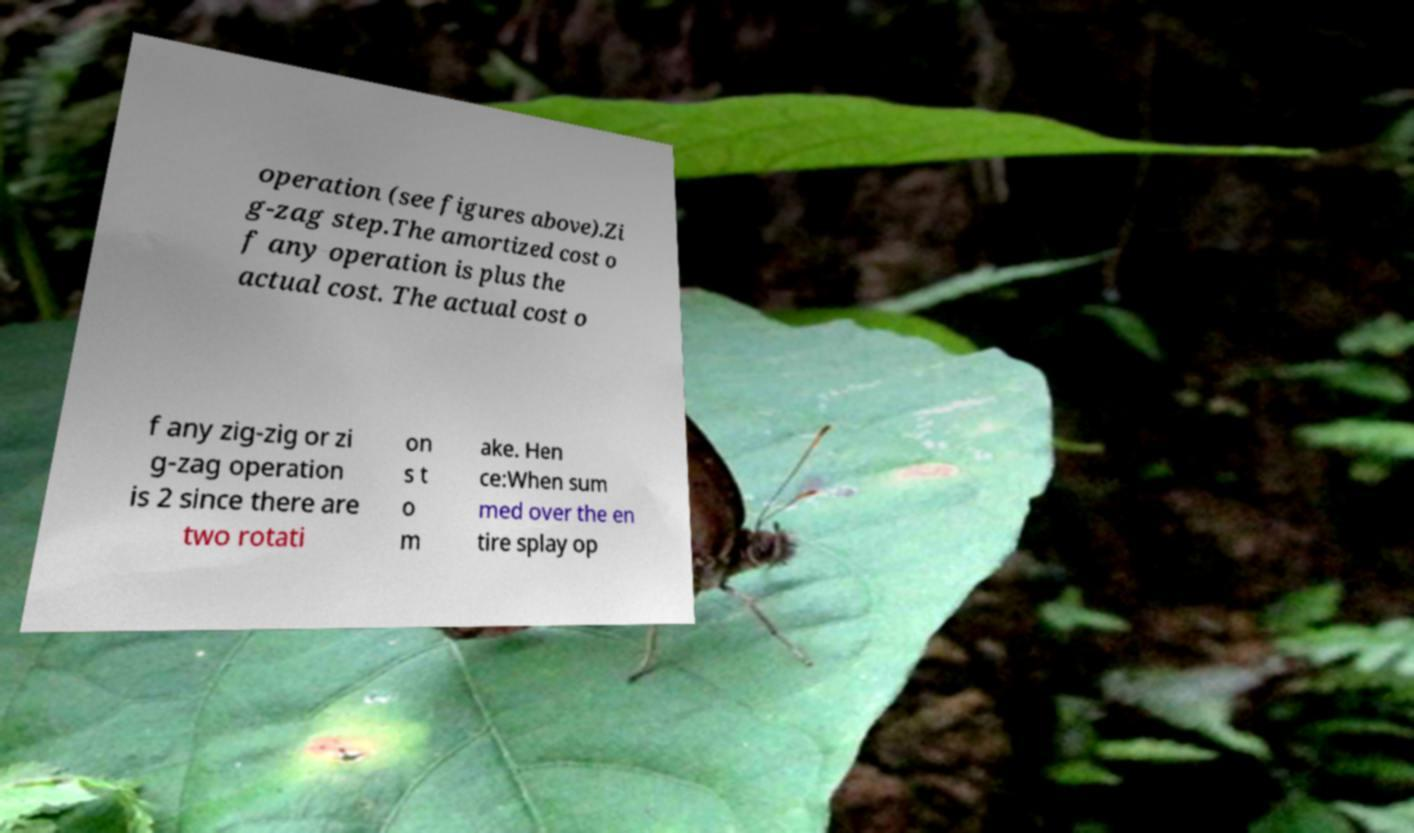Please identify and transcribe the text found in this image. operation (see figures above).Zi g-zag step.The amortized cost o f any operation is plus the actual cost. The actual cost o f any zig-zig or zi g-zag operation is 2 since there are two rotati on s t o m ake. Hen ce:When sum med over the en tire splay op 